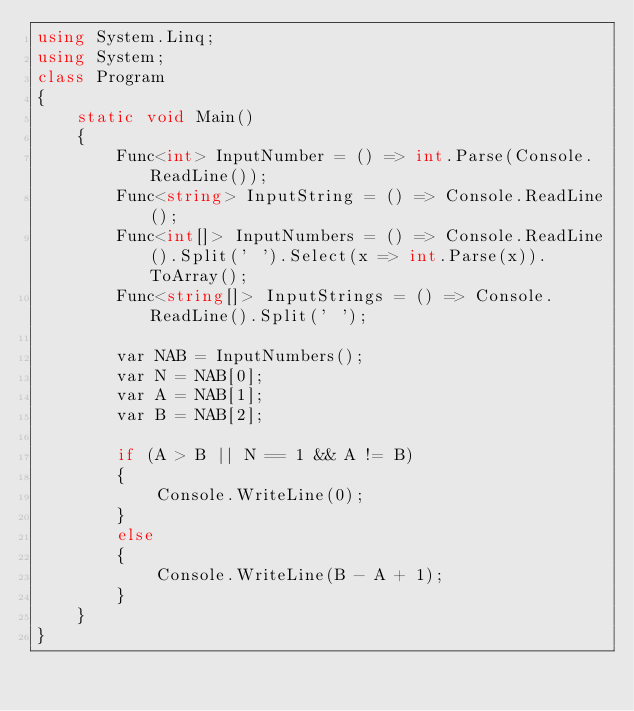<code> <loc_0><loc_0><loc_500><loc_500><_C#_>using System.Linq;
using System;
class Program
{
    static void Main()
    {
        Func<int> InputNumber = () => int.Parse(Console.ReadLine());
        Func<string> InputString = () => Console.ReadLine();
        Func<int[]> InputNumbers = () => Console.ReadLine().Split(' ').Select(x => int.Parse(x)).ToArray();
        Func<string[]> InputStrings = () => Console.ReadLine().Split(' ');

        var NAB = InputNumbers();
        var N = NAB[0];
        var A = NAB[1];
        var B = NAB[2];

        if (A > B || N == 1 && A != B)
        {
            Console.WriteLine(0);
        }
        else
        {
            Console.WriteLine(B - A + 1);
        }
    }
}</code> 